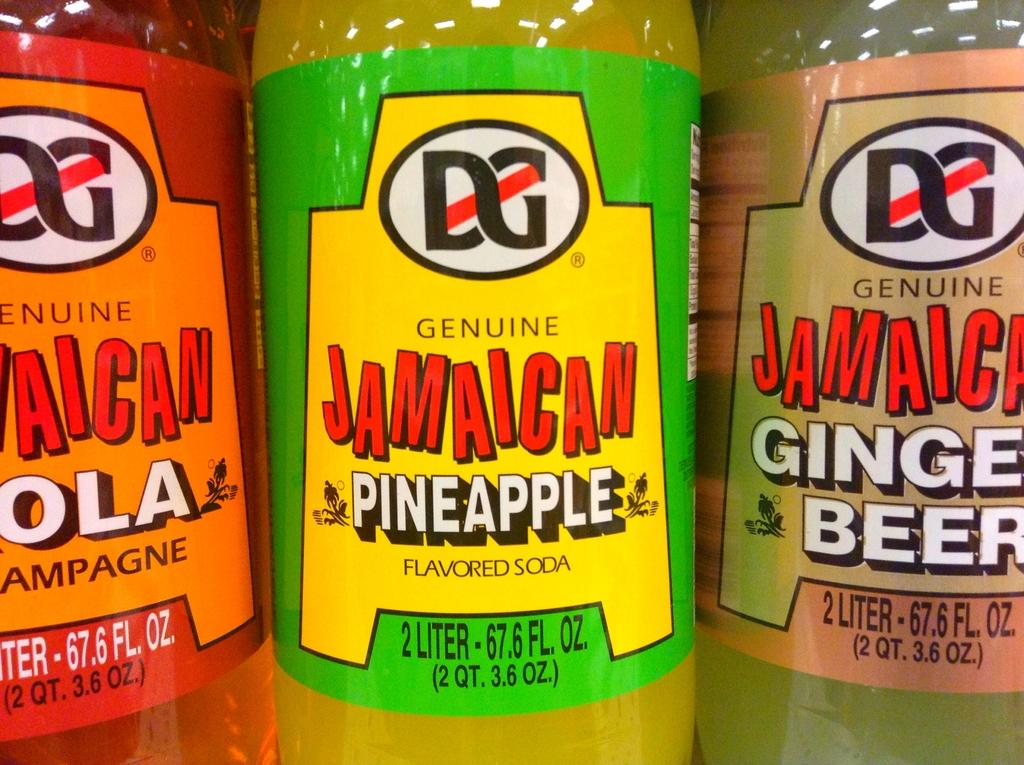Provide a one-sentence caption for the provided image. Three bottles of Jamaican soda (cola, pineapple, and ginger beer flavors) stand side by side. 